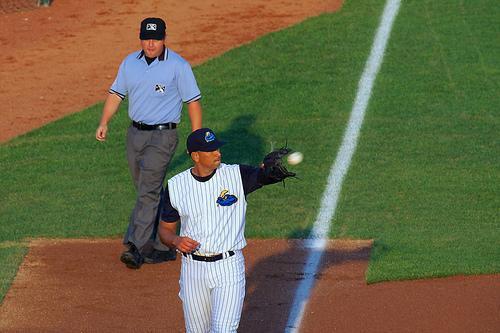How many men are there?
Give a very brief answer. 2. 